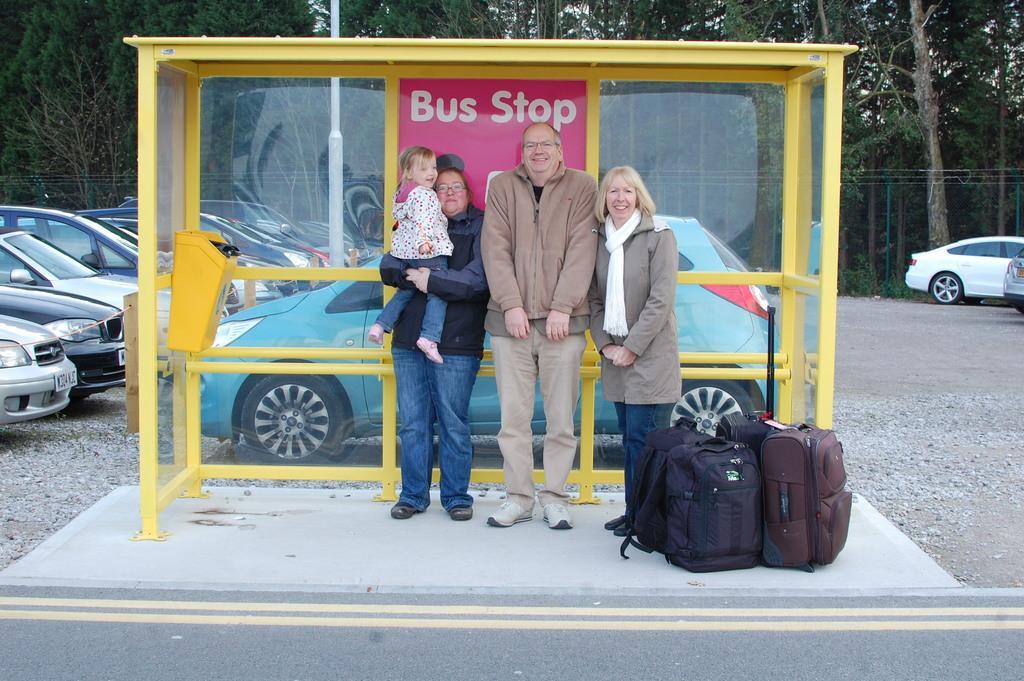Describe this image in one or two sentences. In this picture we can see there are three people standing at the bus stop. On the right side of the people there are some bags. Behind the people there are some vehicles parked on the path, trees, poles and a sky. 